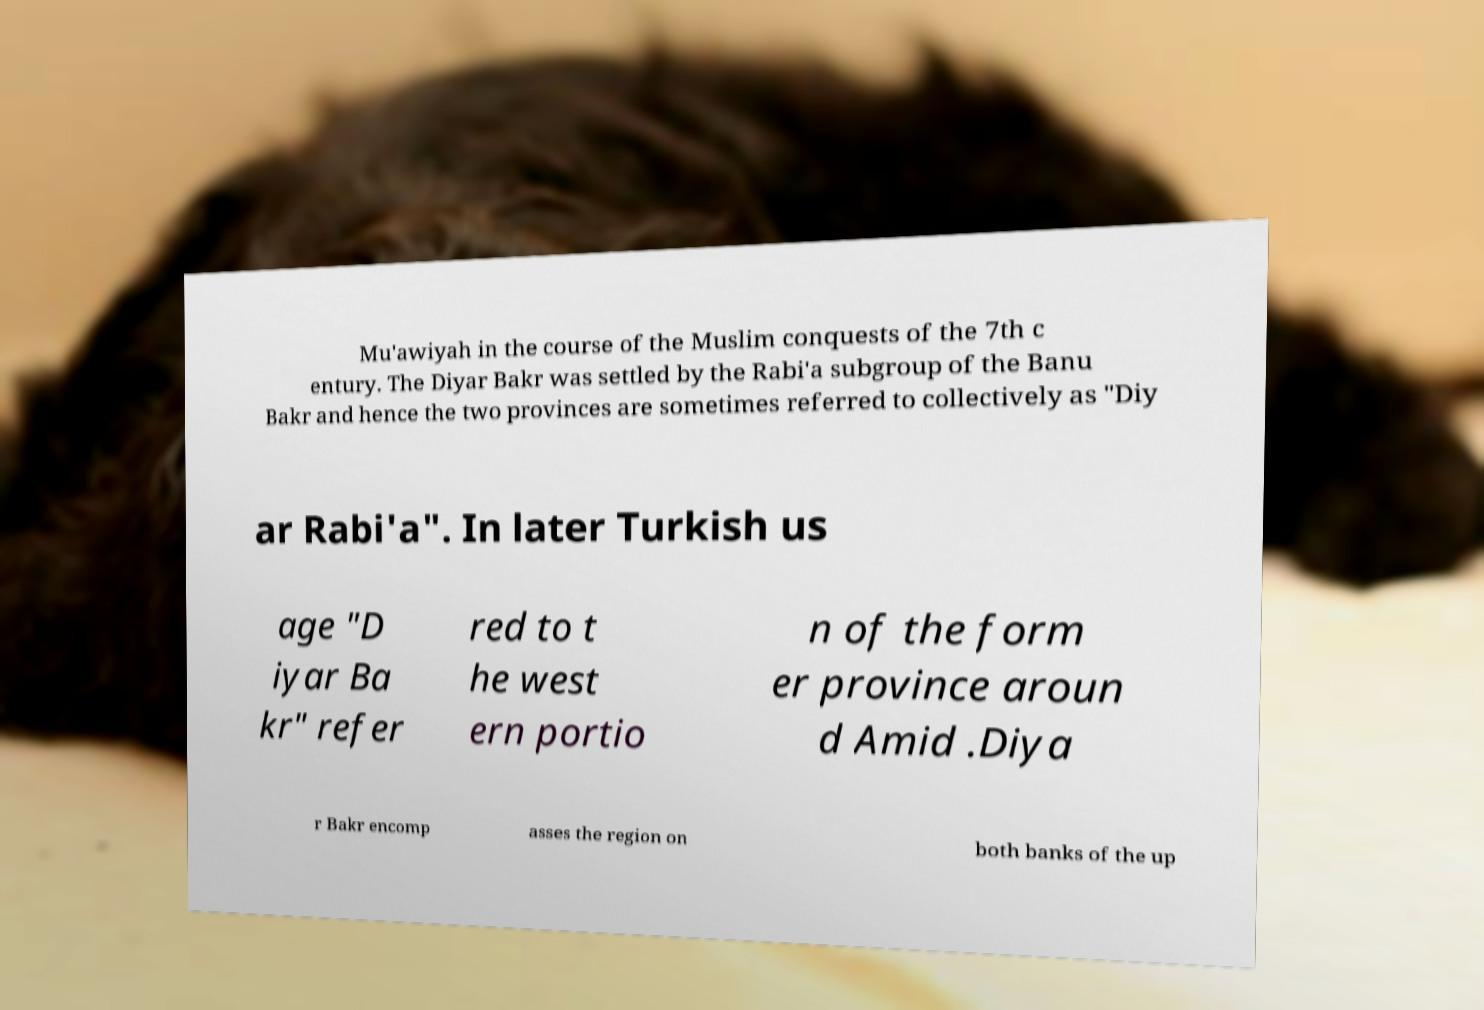For documentation purposes, I need the text within this image transcribed. Could you provide that? Mu'awiyah in the course of the Muslim conquests of the 7th c entury. The Diyar Bakr was settled by the Rabi'a subgroup of the Banu Bakr and hence the two provinces are sometimes referred to collectively as "Diy ar Rabi'a". In later Turkish us age "D iyar Ba kr" refer red to t he west ern portio n of the form er province aroun d Amid .Diya r Bakr encomp asses the region on both banks of the up 